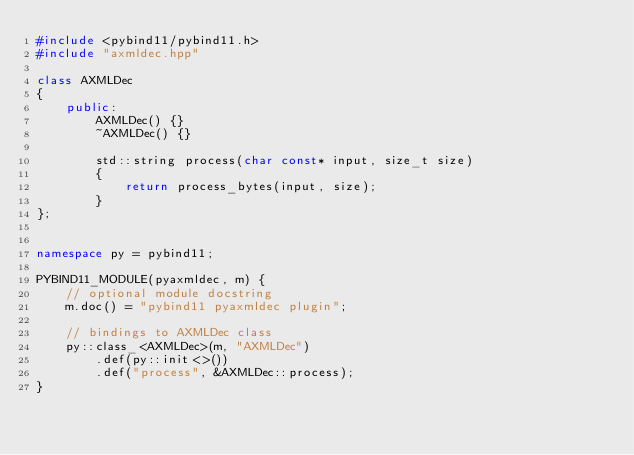Convert code to text. <code><loc_0><loc_0><loc_500><loc_500><_C++_>#include <pybind11/pybind11.h>
#include "axmldec.hpp"

class AXMLDec
{
    public:
        AXMLDec() {}
        ~AXMLDec() {}

        std::string process(char const* input, size_t size)
        {
            return process_bytes(input, size);
        }
};


namespace py = pybind11;

PYBIND11_MODULE(pyaxmldec, m) {
    // optional module docstring
    m.doc() = "pybind11 pyaxmldec plugin";

    // bindings to AXMLDec class
    py::class_<AXMLDec>(m, "AXMLDec")
        .def(py::init<>())
        .def("process", &AXMLDec::process);
}
</code> 